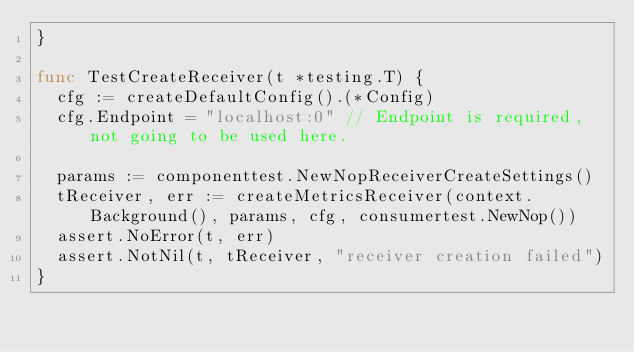Convert code to text. <code><loc_0><loc_0><loc_500><loc_500><_Go_>}

func TestCreateReceiver(t *testing.T) {
	cfg := createDefaultConfig().(*Config)
	cfg.Endpoint = "localhost:0" // Endpoint is required, not going to be used here.

	params := componenttest.NewNopReceiverCreateSettings()
	tReceiver, err := createMetricsReceiver(context.Background(), params, cfg, consumertest.NewNop())
	assert.NoError(t, err)
	assert.NotNil(t, tReceiver, "receiver creation failed")
}
</code> 